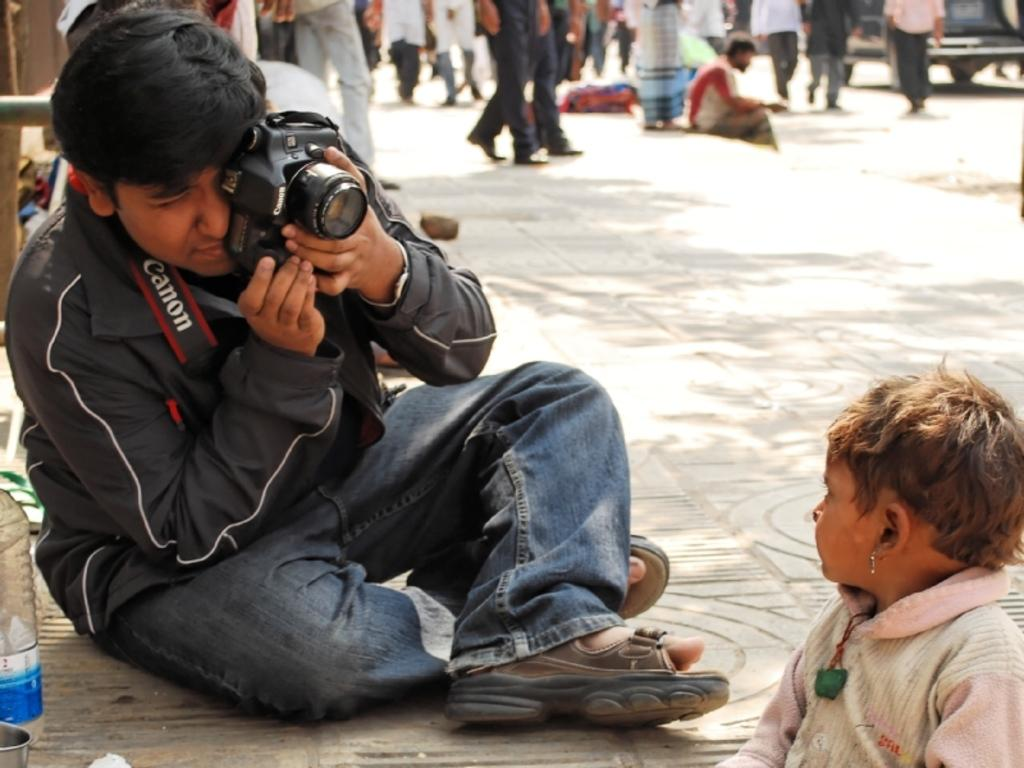What is the man in the image doing? The man is taking a snap with a camera in the image. What else can be seen in the image besides the man with the camera? There are people walking on the road in the image, as well as a bottle visible. What type of grape is the man holding in the image? There is no grape present in the image; the man is holding a camera. How does the duck contribute to the scene in the image? There is no duck present in the image; it is not part of the scene. 